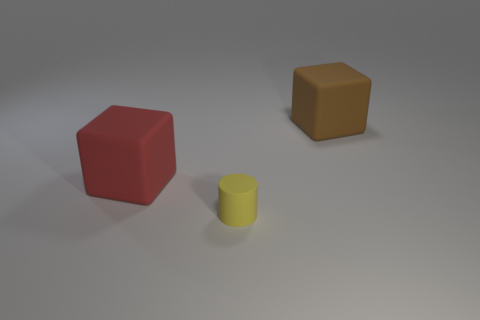Add 1 yellow rubber objects. How many objects exist? 4 Subtract all cylinders. How many objects are left? 2 Subtract all large purple cylinders. Subtract all big cubes. How many objects are left? 1 Add 1 small rubber objects. How many small rubber objects are left? 2 Add 2 brown matte objects. How many brown matte objects exist? 3 Subtract 0 gray balls. How many objects are left? 3 